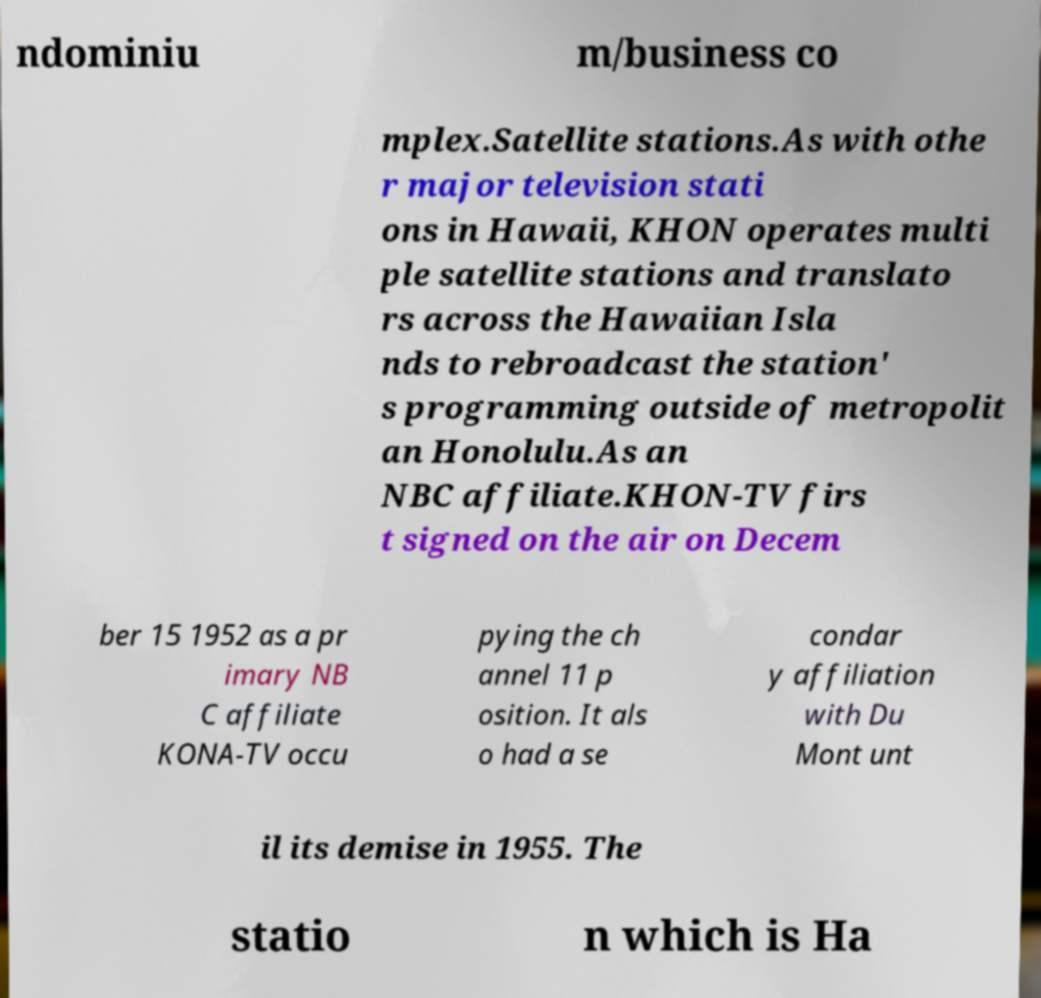There's text embedded in this image that I need extracted. Can you transcribe it verbatim? ndominiu m/business co mplex.Satellite stations.As with othe r major television stati ons in Hawaii, KHON operates multi ple satellite stations and translato rs across the Hawaiian Isla nds to rebroadcast the station' s programming outside of metropolit an Honolulu.As an NBC affiliate.KHON-TV firs t signed on the air on Decem ber 15 1952 as a pr imary NB C affiliate KONA-TV occu pying the ch annel 11 p osition. It als o had a se condar y affiliation with Du Mont unt il its demise in 1955. The statio n which is Ha 